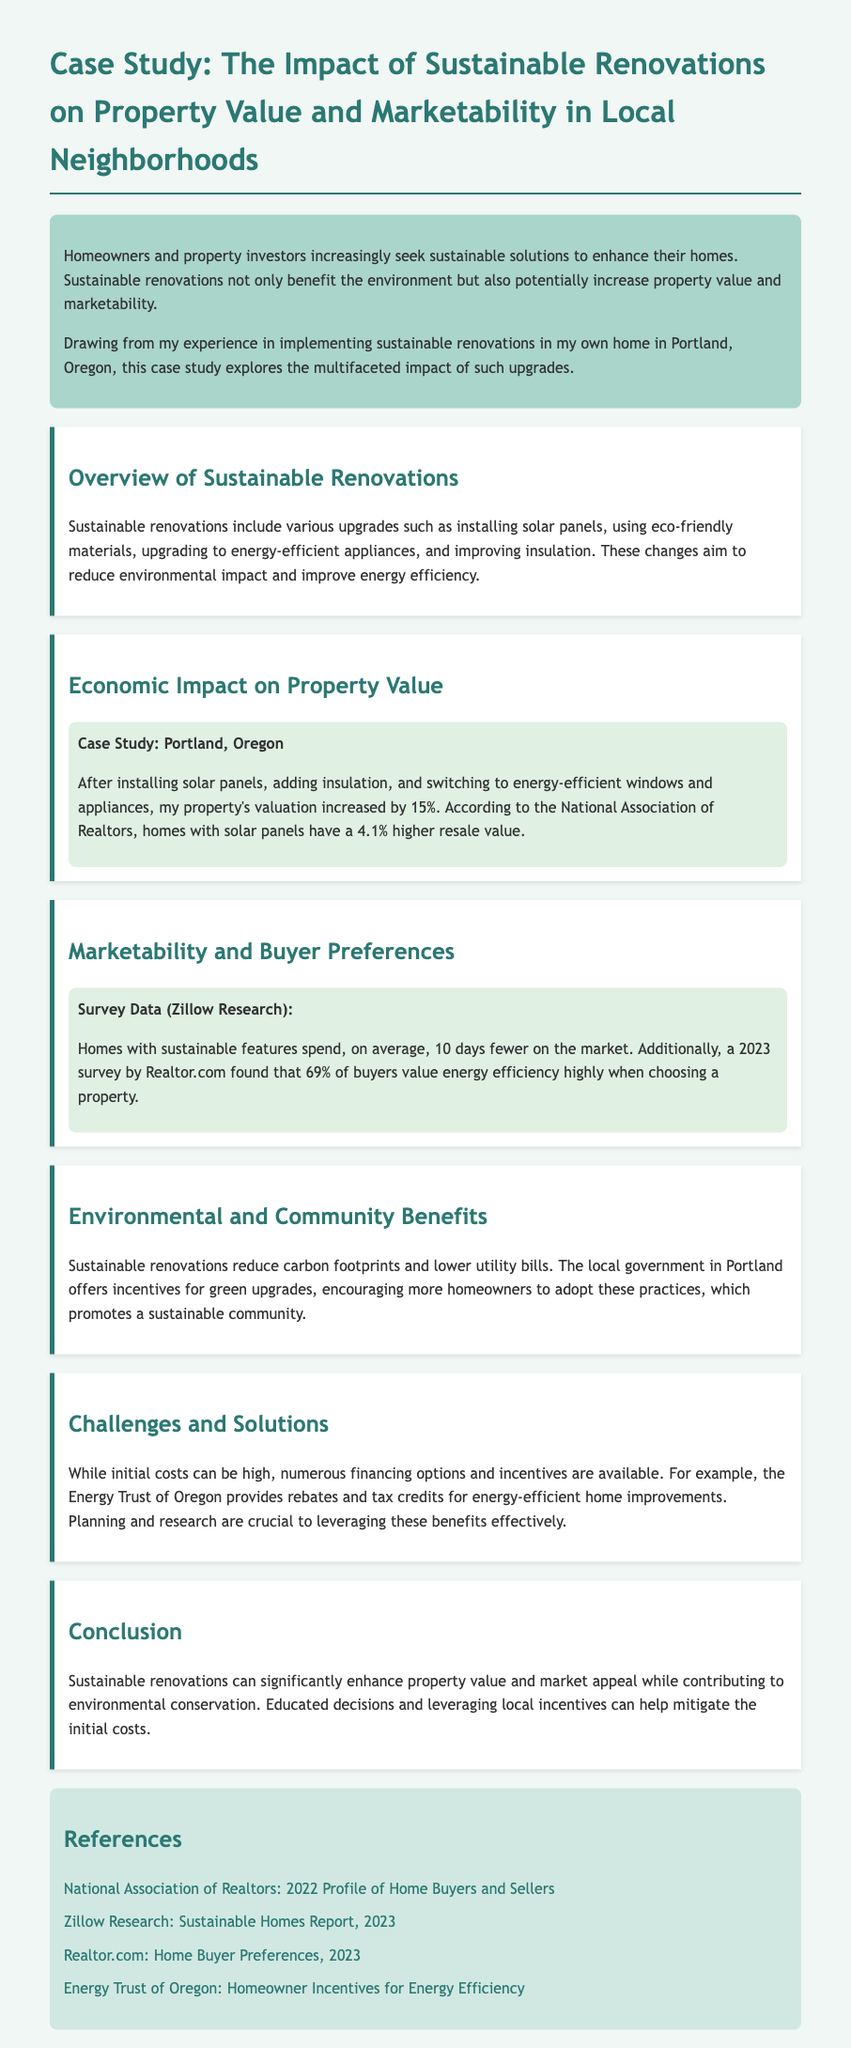What is the primary benefit of sustainable renovations? The document states that sustainable renovations benefit the environment and potentially increase property value and marketability.
Answer: increase property value and marketability What percentage did the property valuation increase after renovations? The case study mentions a 15% increase in property valuation due to the renovations.
Answer: 15% Which organization reports that homes with solar panels have a higher resale value? The National Association of Realtors provides this information regarding solar panels and resale value.
Answer: National Association of Realtors How many days fewer do homes with sustainable features spend on the market on average? The survey data indicates that homes with sustainable features typically spend 10 days fewer on the market.
Answer: 10 days What percentage of buyers value energy efficiency highly according to the 2023 survey? The document states that 69% of buyers find energy efficiency highly valuable when choosing a property.
Answer: 69% What is cited as a challenge to implementing sustainable renovations? The document mentions that high initial costs pose a challenge to homeowners considering sustainable renovations.
Answer: high initial costs Which local entity offers incentives for green upgrades in Portland? The document specifies that the local government in Portland supports green upgrades through incentives.
Answer: local government What does the Energy Trust of Oregon provide for energy-efficient home improvements? The Energy Trust of Oregon offers rebates and tax credits for energy-efficient renovations.
Answer: rebates and tax credits 